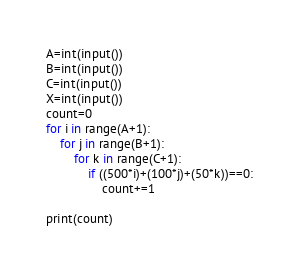Convert code to text. <code><loc_0><loc_0><loc_500><loc_500><_Python_>A=int(input())
B=int(input())
C=int(input())
X=int(input())
count=0
for i in range(A+1):
    for j in range(B+1):
        for k in range(C+1):
            if ((500*i)+(100*j)+(50*k))==0:
                count+=1

print(count)</code> 